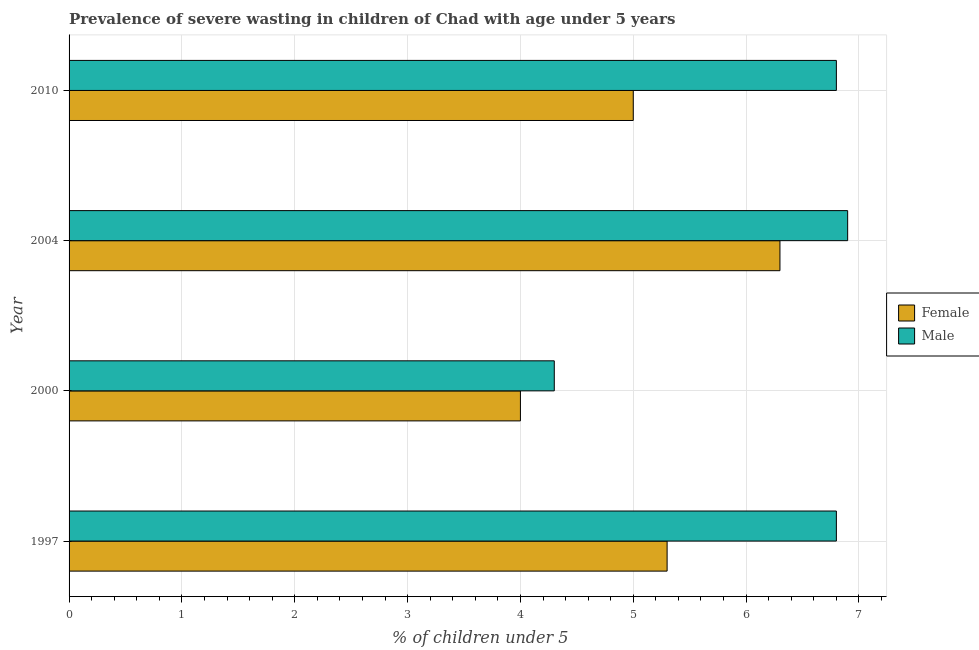Are the number of bars per tick equal to the number of legend labels?
Provide a succinct answer. Yes. How many bars are there on the 2nd tick from the top?
Ensure brevity in your answer.  2. In how many cases, is the number of bars for a given year not equal to the number of legend labels?
Offer a terse response. 0. Across all years, what is the maximum percentage of undernourished male children?
Your answer should be compact. 6.9. Across all years, what is the minimum percentage of undernourished male children?
Offer a very short reply. 4.3. In which year was the percentage of undernourished female children maximum?
Make the answer very short. 2004. In which year was the percentage of undernourished male children minimum?
Your answer should be compact. 2000. What is the total percentage of undernourished male children in the graph?
Provide a succinct answer. 24.8. What is the difference between the percentage of undernourished male children in 2000 and the percentage of undernourished female children in 2010?
Provide a succinct answer. -0.7. In the year 1997, what is the difference between the percentage of undernourished female children and percentage of undernourished male children?
Give a very brief answer. -1.5. In how many years, is the percentage of undernourished female children greater than 6 %?
Provide a short and direct response. 1. What is the ratio of the percentage of undernourished female children in 2000 to that in 2004?
Give a very brief answer. 0.64. What is the difference between the highest and the second highest percentage of undernourished female children?
Keep it short and to the point. 1. What is the difference between the highest and the lowest percentage of undernourished female children?
Keep it short and to the point. 2.3. Is the sum of the percentage of undernourished female children in 1997 and 2004 greater than the maximum percentage of undernourished male children across all years?
Make the answer very short. Yes. How many bars are there?
Make the answer very short. 8. What is the difference between two consecutive major ticks on the X-axis?
Give a very brief answer. 1. Does the graph contain any zero values?
Make the answer very short. No. What is the title of the graph?
Your answer should be compact. Prevalence of severe wasting in children of Chad with age under 5 years. Does "Long-term debt" appear as one of the legend labels in the graph?
Offer a terse response. No. What is the label or title of the X-axis?
Provide a short and direct response.  % of children under 5. What is the label or title of the Y-axis?
Your response must be concise. Year. What is the  % of children under 5 in Female in 1997?
Ensure brevity in your answer.  5.3. What is the  % of children under 5 of Male in 1997?
Your answer should be very brief. 6.8. What is the  % of children under 5 of Male in 2000?
Ensure brevity in your answer.  4.3. What is the  % of children under 5 of Female in 2004?
Make the answer very short. 6.3. What is the  % of children under 5 in Male in 2004?
Provide a short and direct response. 6.9. What is the  % of children under 5 of Female in 2010?
Offer a terse response. 5. What is the  % of children under 5 in Male in 2010?
Provide a short and direct response. 6.8. Across all years, what is the maximum  % of children under 5 in Female?
Your response must be concise. 6.3. Across all years, what is the maximum  % of children under 5 of Male?
Give a very brief answer. 6.9. Across all years, what is the minimum  % of children under 5 of Male?
Offer a terse response. 4.3. What is the total  % of children under 5 in Female in the graph?
Provide a short and direct response. 20.6. What is the total  % of children under 5 of Male in the graph?
Ensure brevity in your answer.  24.8. What is the difference between the  % of children under 5 in Female in 1997 and that in 2000?
Your answer should be compact. 1.3. What is the difference between the  % of children under 5 of Male in 1997 and that in 2000?
Ensure brevity in your answer.  2.5. What is the difference between the  % of children under 5 in Female in 1997 and that in 2004?
Keep it short and to the point. -1. What is the difference between the  % of children under 5 in Male in 1997 and that in 2010?
Your response must be concise. 0. What is the difference between the  % of children under 5 of Male in 2000 and that in 2004?
Give a very brief answer. -2.6. What is the difference between the  % of children under 5 in Male in 2000 and that in 2010?
Provide a succinct answer. -2.5. What is the difference between the  % of children under 5 of Female in 2004 and that in 2010?
Offer a terse response. 1.3. What is the difference between the  % of children under 5 of Female in 1997 and the  % of children under 5 of Male in 2010?
Your response must be concise. -1.5. What is the difference between the  % of children under 5 of Female in 2004 and the  % of children under 5 of Male in 2010?
Ensure brevity in your answer.  -0.5. What is the average  % of children under 5 in Female per year?
Ensure brevity in your answer.  5.15. What is the average  % of children under 5 of Male per year?
Provide a short and direct response. 6.2. In the year 1997, what is the difference between the  % of children under 5 of Female and  % of children under 5 of Male?
Provide a succinct answer. -1.5. In the year 2000, what is the difference between the  % of children under 5 of Female and  % of children under 5 of Male?
Offer a very short reply. -0.3. In the year 2010, what is the difference between the  % of children under 5 in Female and  % of children under 5 in Male?
Provide a succinct answer. -1.8. What is the ratio of the  % of children under 5 of Female in 1997 to that in 2000?
Offer a very short reply. 1.32. What is the ratio of the  % of children under 5 in Male in 1997 to that in 2000?
Keep it short and to the point. 1.58. What is the ratio of the  % of children under 5 of Female in 1997 to that in 2004?
Your response must be concise. 0.84. What is the ratio of the  % of children under 5 in Male in 1997 to that in 2004?
Give a very brief answer. 0.99. What is the ratio of the  % of children under 5 of Female in 1997 to that in 2010?
Your response must be concise. 1.06. What is the ratio of the  % of children under 5 in Male in 1997 to that in 2010?
Provide a succinct answer. 1. What is the ratio of the  % of children under 5 in Female in 2000 to that in 2004?
Your response must be concise. 0.63. What is the ratio of the  % of children under 5 of Male in 2000 to that in 2004?
Your answer should be compact. 0.62. What is the ratio of the  % of children under 5 of Female in 2000 to that in 2010?
Provide a short and direct response. 0.8. What is the ratio of the  % of children under 5 of Male in 2000 to that in 2010?
Make the answer very short. 0.63. What is the ratio of the  % of children under 5 in Female in 2004 to that in 2010?
Your answer should be very brief. 1.26. What is the ratio of the  % of children under 5 of Male in 2004 to that in 2010?
Offer a terse response. 1.01. What is the difference between the highest and the second highest  % of children under 5 in Female?
Ensure brevity in your answer.  1. What is the difference between the highest and the second highest  % of children under 5 of Male?
Offer a very short reply. 0.1. What is the difference between the highest and the lowest  % of children under 5 in Female?
Your response must be concise. 2.3. 